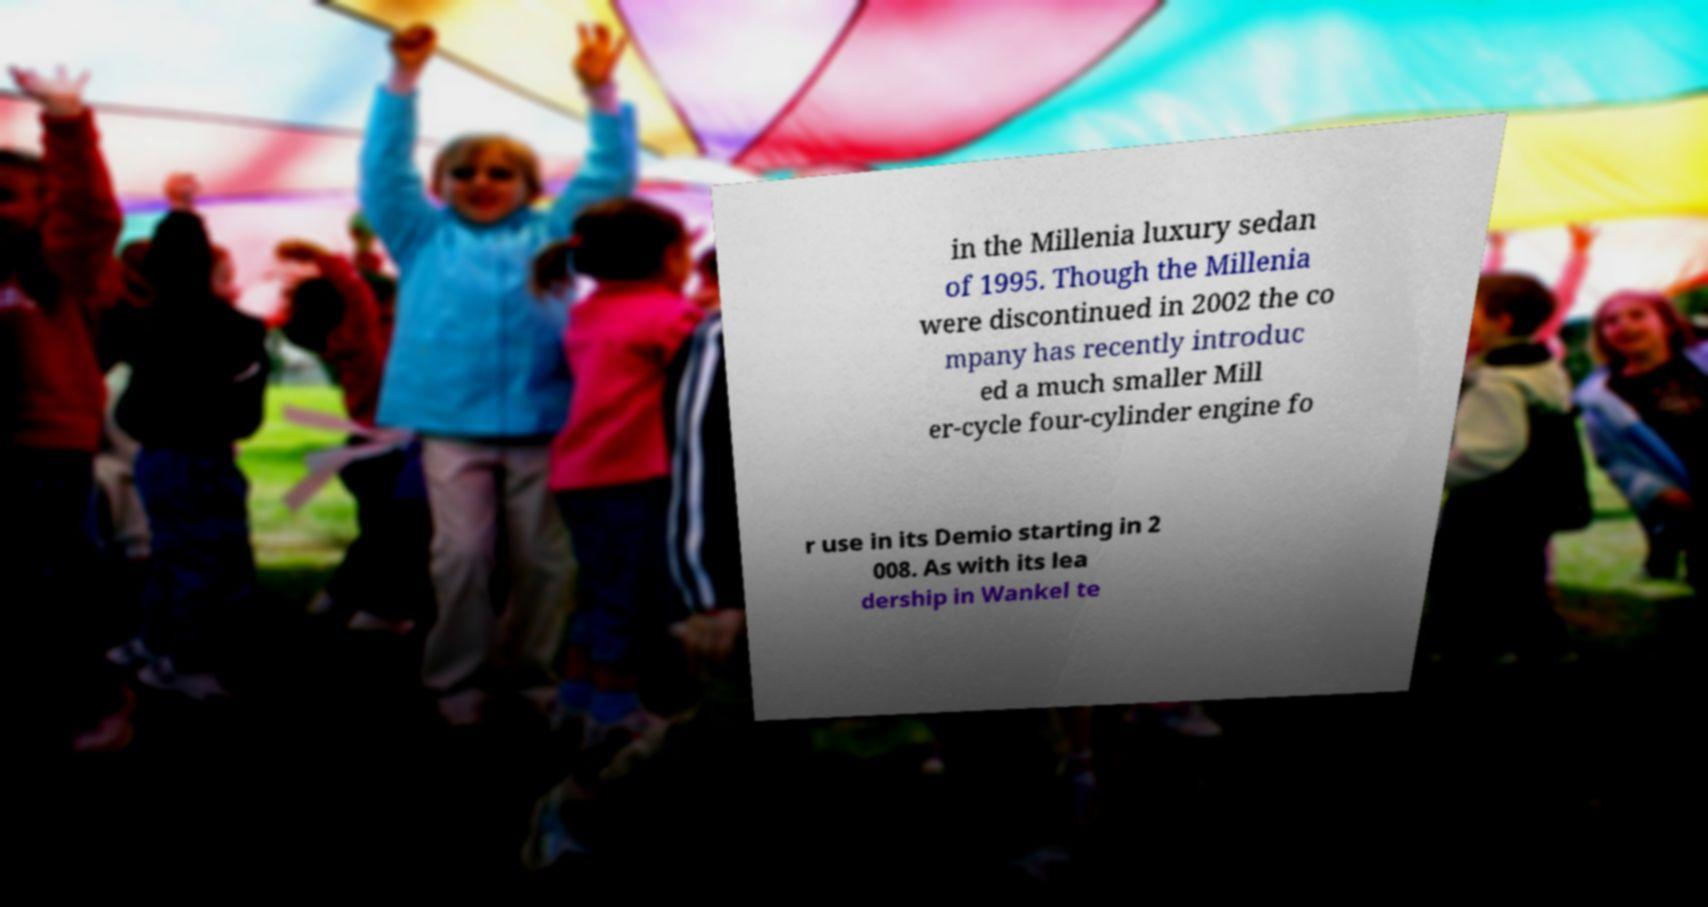What messages or text are displayed in this image? I need them in a readable, typed format. in the Millenia luxury sedan of 1995. Though the Millenia were discontinued in 2002 the co mpany has recently introduc ed a much smaller Mill er-cycle four-cylinder engine fo r use in its Demio starting in 2 008. As with its lea dership in Wankel te 